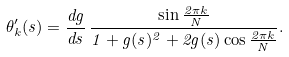Convert formula to latex. <formula><loc_0><loc_0><loc_500><loc_500>\theta _ { k } ^ { \prime } ( s ) = \frac { d g } { d s } \, \frac { \sin \frac { 2 \pi k } { N } } { 1 + g ( s ) ^ { 2 } + 2 g ( s ) \cos \frac { 2 \pi k } { N } } .</formula> 